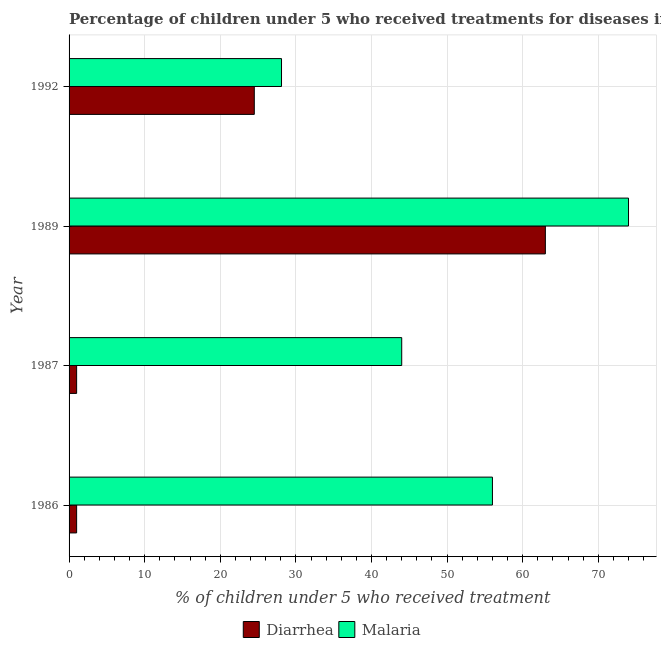Are the number of bars per tick equal to the number of legend labels?
Provide a succinct answer. Yes. How many bars are there on the 3rd tick from the bottom?
Offer a very short reply. 2. What is the percentage of children who received treatment for malaria in 1992?
Offer a terse response. 28.1. Across all years, what is the maximum percentage of children who received treatment for malaria?
Offer a terse response. 74. Across all years, what is the minimum percentage of children who received treatment for malaria?
Keep it short and to the point. 28.1. What is the total percentage of children who received treatment for diarrhoea in the graph?
Provide a succinct answer. 89.5. What is the difference between the percentage of children who received treatment for diarrhoea in 1987 and that in 1992?
Your answer should be compact. -23.5. What is the difference between the percentage of children who received treatment for diarrhoea in 1986 and the percentage of children who received treatment for malaria in 1992?
Your answer should be compact. -27.1. What is the average percentage of children who received treatment for diarrhoea per year?
Make the answer very short. 22.38. In the year 1992, what is the difference between the percentage of children who received treatment for malaria and percentage of children who received treatment for diarrhoea?
Your answer should be compact. 3.6. What is the ratio of the percentage of children who received treatment for malaria in 1987 to that in 1992?
Your response must be concise. 1.57. What is the difference between the highest and the lowest percentage of children who received treatment for diarrhoea?
Offer a very short reply. 62. Is the sum of the percentage of children who received treatment for malaria in 1987 and 1989 greater than the maximum percentage of children who received treatment for diarrhoea across all years?
Offer a terse response. Yes. What does the 1st bar from the top in 1989 represents?
Provide a short and direct response. Malaria. What does the 1st bar from the bottom in 1989 represents?
Your answer should be very brief. Diarrhea. Are all the bars in the graph horizontal?
Offer a very short reply. Yes. How many years are there in the graph?
Keep it short and to the point. 4. Does the graph contain grids?
Provide a succinct answer. Yes. Where does the legend appear in the graph?
Offer a very short reply. Bottom center. What is the title of the graph?
Make the answer very short. Percentage of children under 5 who received treatments for diseases in Guinea. Does "Constant 2005 US$" appear as one of the legend labels in the graph?
Keep it short and to the point. No. What is the label or title of the X-axis?
Provide a succinct answer. % of children under 5 who received treatment. What is the % of children under 5 who received treatment in Malaria in 1987?
Your response must be concise. 44. What is the % of children under 5 who received treatment in Diarrhea in 1989?
Your answer should be compact. 63. What is the % of children under 5 who received treatment of Diarrhea in 1992?
Keep it short and to the point. 24.5. What is the % of children under 5 who received treatment in Malaria in 1992?
Your response must be concise. 28.1. Across all years, what is the maximum % of children under 5 who received treatment of Malaria?
Keep it short and to the point. 74. Across all years, what is the minimum % of children under 5 who received treatment of Diarrhea?
Offer a very short reply. 1. Across all years, what is the minimum % of children under 5 who received treatment in Malaria?
Provide a short and direct response. 28.1. What is the total % of children under 5 who received treatment of Diarrhea in the graph?
Keep it short and to the point. 89.5. What is the total % of children under 5 who received treatment of Malaria in the graph?
Make the answer very short. 202.1. What is the difference between the % of children under 5 who received treatment of Diarrhea in 1986 and that in 1989?
Provide a short and direct response. -62. What is the difference between the % of children under 5 who received treatment of Diarrhea in 1986 and that in 1992?
Make the answer very short. -23.5. What is the difference between the % of children under 5 who received treatment in Malaria in 1986 and that in 1992?
Offer a terse response. 27.9. What is the difference between the % of children under 5 who received treatment of Diarrhea in 1987 and that in 1989?
Your answer should be very brief. -62. What is the difference between the % of children under 5 who received treatment in Diarrhea in 1987 and that in 1992?
Your response must be concise. -23.5. What is the difference between the % of children under 5 who received treatment in Malaria in 1987 and that in 1992?
Give a very brief answer. 15.9. What is the difference between the % of children under 5 who received treatment of Diarrhea in 1989 and that in 1992?
Keep it short and to the point. 38.5. What is the difference between the % of children under 5 who received treatment in Malaria in 1989 and that in 1992?
Ensure brevity in your answer.  45.9. What is the difference between the % of children under 5 who received treatment of Diarrhea in 1986 and the % of children under 5 who received treatment of Malaria in 1987?
Provide a succinct answer. -43. What is the difference between the % of children under 5 who received treatment in Diarrhea in 1986 and the % of children under 5 who received treatment in Malaria in 1989?
Ensure brevity in your answer.  -73. What is the difference between the % of children under 5 who received treatment in Diarrhea in 1986 and the % of children under 5 who received treatment in Malaria in 1992?
Your answer should be very brief. -27.1. What is the difference between the % of children under 5 who received treatment of Diarrhea in 1987 and the % of children under 5 who received treatment of Malaria in 1989?
Make the answer very short. -73. What is the difference between the % of children under 5 who received treatment of Diarrhea in 1987 and the % of children under 5 who received treatment of Malaria in 1992?
Your response must be concise. -27.1. What is the difference between the % of children under 5 who received treatment in Diarrhea in 1989 and the % of children under 5 who received treatment in Malaria in 1992?
Give a very brief answer. 34.9. What is the average % of children under 5 who received treatment of Diarrhea per year?
Your answer should be compact. 22.38. What is the average % of children under 5 who received treatment of Malaria per year?
Provide a short and direct response. 50.52. In the year 1986, what is the difference between the % of children under 5 who received treatment of Diarrhea and % of children under 5 who received treatment of Malaria?
Offer a terse response. -55. In the year 1987, what is the difference between the % of children under 5 who received treatment of Diarrhea and % of children under 5 who received treatment of Malaria?
Give a very brief answer. -43. What is the ratio of the % of children under 5 who received treatment of Malaria in 1986 to that in 1987?
Keep it short and to the point. 1.27. What is the ratio of the % of children under 5 who received treatment in Diarrhea in 1986 to that in 1989?
Your answer should be compact. 0.02. What is the ratio of the % of children under 5 who received treatment in Malaria in 1986 to that in 1989?
Offer a very short reply. 0.76. What is the ratio of the % of children under 5 who received treatment of Diarrhea in 1986 to that in 1992?
Give a very brief answer. 0.04. What is the ratio of the % of children under 5 who received treatment of Malaria in 1986 to that in 1992?
Provide a succinct answer. 1.99. What is the ratio of the % of children under 5 who received treatment in Diarrhea in 1987 to that in 1989?
Make the answer very short. 0.02. What is the ratio of the % of children under 5 who received treatment of Malaria in 1987 to that in 1989?
Give a very brief answer. 0.59. What is the ratio of the % of children under 5 who received treatment of Diarrhea in 1987 to that in 1992?
Offer a very short reply. 0.04. What is the ratio of the % of children under 5 who received treatment in Malaria in 1987 to that in 1992?
Provide a succinct answer. 1.57. What is the ratio of the % of children under 5 who received treatment in Diarrhea in 1989 to that in 1992?
Offer a terse response. 2.57. What is the ratio of the % of children under 5 who received treatment in Malaria in 1989 to that in 1992?
Your answer should be compact. 2.63. What is the difference between the highest and the second highest % of children under 5 who received treatment in Diarrhea?
Provide a short and direct response. 38.5. What is the difference between the highest and the second highest % of children under 5 who received treatment of Malaria?
Offer a very short reply. 18. What is the difference between the highest and the lowest % of children under 5 who received treatment of Diarrhea?
Ensure brevity in your answer.  62. What is the difference between the highest and the lowest % of children under 5 who received treatment in Malaria?
Make the answer very short. 45.9. 